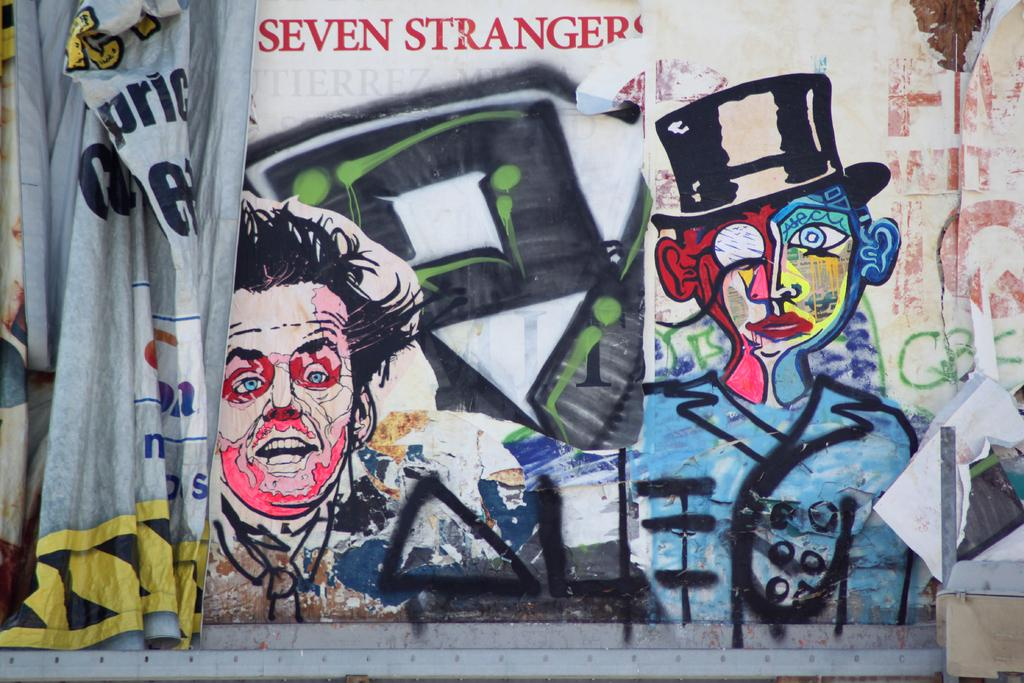What is the main feature of the image? There is a big wall with colorful images in the image. What else can be seen on the wall? There is text on the wall. What other text is present in the image? There is a big banner with text in the image. What might be the purpose of the objects on the surface in the image? The objects on the surface could be decorative or functional. What type of juice can be seen spilled on the wall in the image? There is no juice spilled on the wall in the image. 